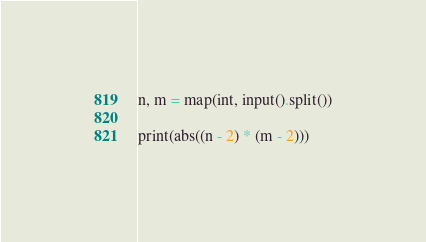Convert code to text. <code><loc_0><loc_0><loc_500><loc_500><_Python_>n, m = map(int, input().split())

print(abs((n - 2) * (m - 2)))
</code> 